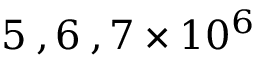Convert formula to latex. <formula><loc_0><loc_0><loc_500><loc_500>5 \, , 6 \, , 7 \times 1 0 ^ { 6 }</formula> 